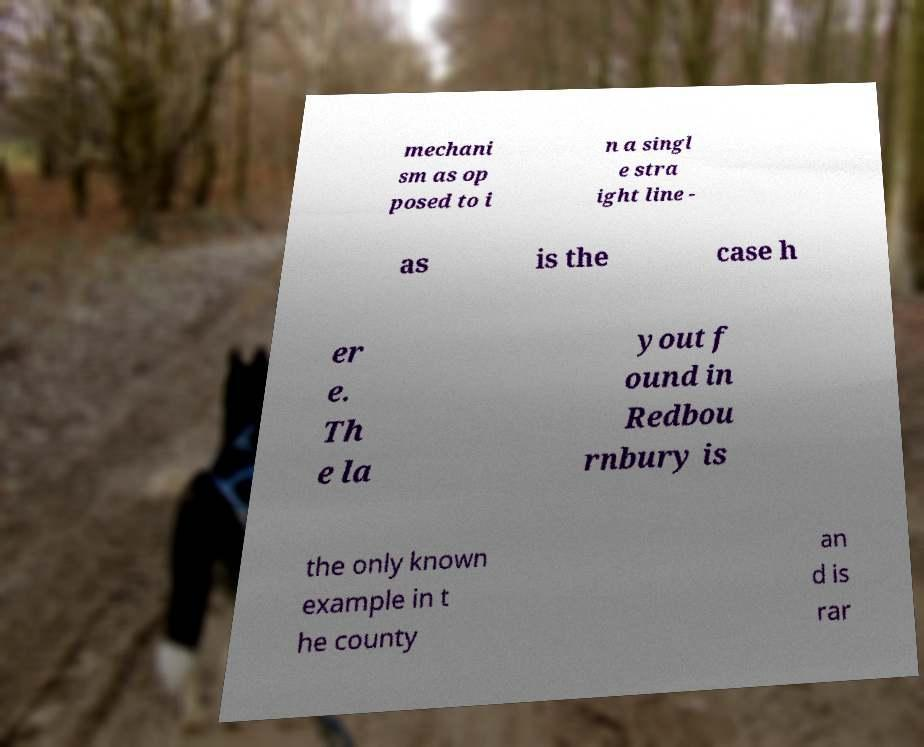Can you read and provide the text displayed in the image?This photo seems to have some interesting text. Can you extract and type it out for me? mechani sm as op posed to i n a singl e stra ight line - as is the case h er e. Th e la yout f ound in Redbou rnbury is the only known example in t he county an d is rar 